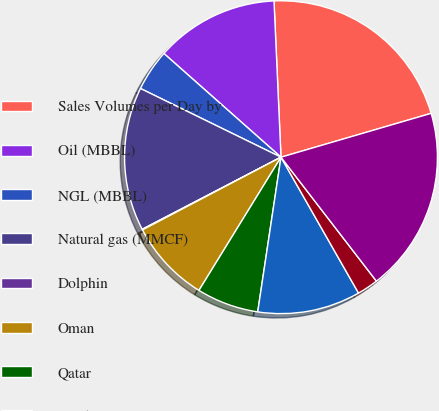Convert chart. <chart><loc_0><loc_0><loc_500><loc_500><pie_chart><fcel>Sales Volumes per Day by<fcel>Oil (MBBL)<fcel>NGL (MBBL)<fcel>Natural gas (MMCF)<fcel>Dolphin<fcel>Oman<fcel>Qatar<fcel>Total<fcel>Al Hosn Gas<fcel>Total Sales Volumes (MBOE) (a)<nl><fcel>21.19%<fcel>12.75%<fcel>4.3%<fcel>14.86%<fcel>0.07%<fcel>8.52%<fcel>6.41%<fcel>10.63%<fcel>2.19%<fcel>19.08%<nl></chart> 